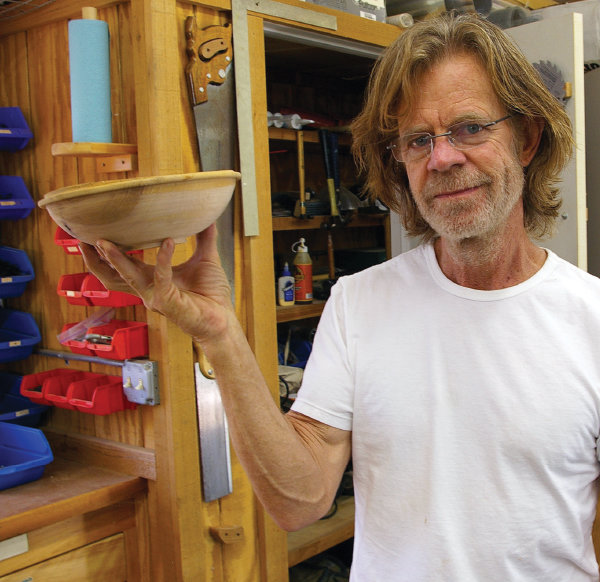What type of environment is pictured in this image? The image shows a well-organized woodworking workshop. There are shelves with an assortment of tools and woodworking materials suggesting that it is a space designed for crafting and constructing objects out of wood. 